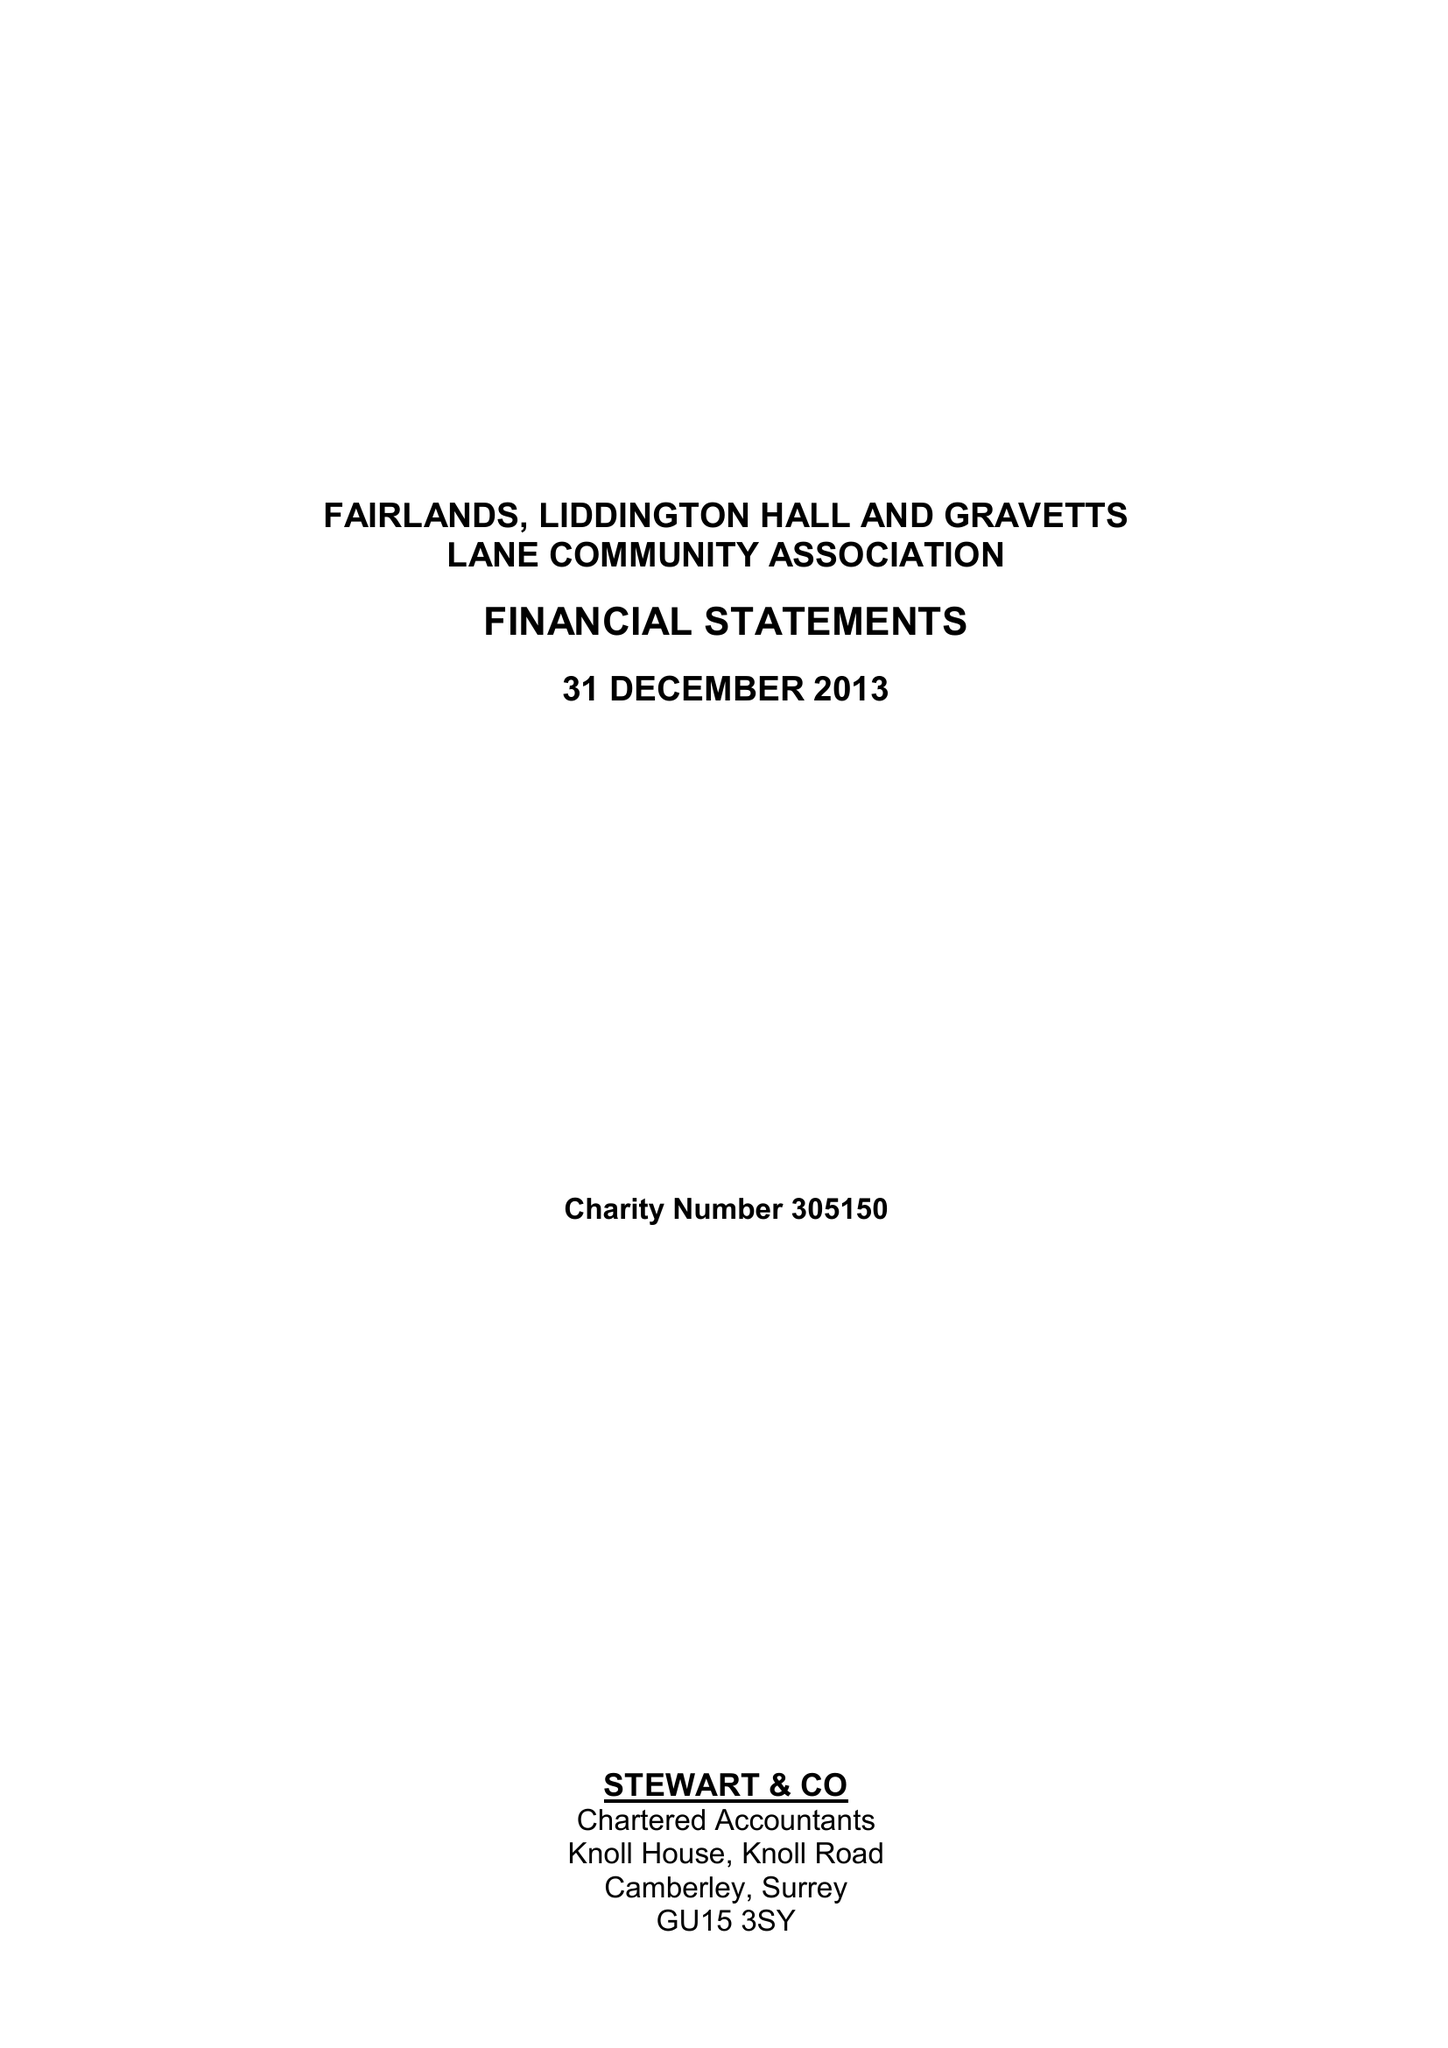What is the value for the charity_number?
Answer the question using a single word or phrase. 305150 